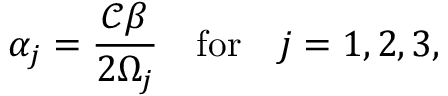Convert formula to latex. <formula><loc_0><loc_0><loc_500><loc_500>\alpha _ { j } = \frac { \ m a t h s c r { C } \beta } { 2 \Omega _ { j } } \quad f o r \quad j = 1 , 2 , 3 ,</formula> 